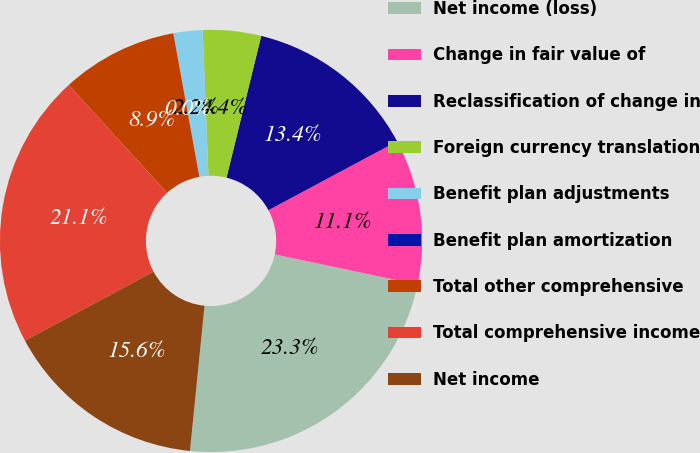<chart> <loc_0><loc_0><loc_500><loc_500><pie_chart><fcel>Net income (loss)<fcel>Change in fair value of<fcel>Reclassification of change in<fcel>Foreign currency translation<fcel>Benefit plan adjustments<fcel>Benefit plan amortization<fcel>Total other comprehensive<fcel>Total comprehensive income<fcel>Net income<nl><fcel>23.28%<fcel>11.13%<fcel>13.36%<fcel>4.45%<fcel>2.23%<fcel>0.0%<fcel>8.91%<fcel>21.06%<fcel>15.58%<nl></chart> 